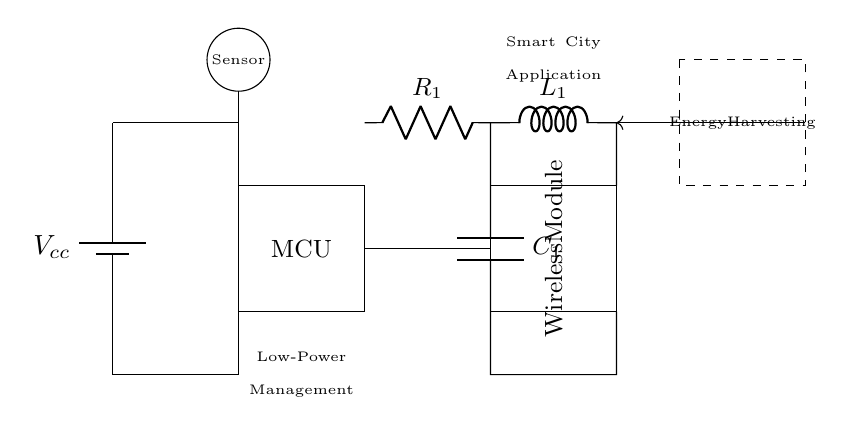What is the power source in this circuit? The power source is a battery, labeled as Vcc. It provides the necessary voltage to the circuit components.
Answer: battery What component is represented by the rectangle on the left side? The rectangle on the left side represents the microcontroller, indicated by the label MCU. A microcontroller processes signals and commands in the circuit.
Answer: MCU What is the function of the energy harvesting component? The energy harvesting component, depicted by the dashed rectangle, is designed to collect and convert energy from the environment to supply power to the circuit, enhancing its efficiency.
Answer: collects energy What type of circuit is this? This circuit is a low-power circuit intended for wireless sensors in smart city applications, which is reflective in its design and components used.
Answer: low-power Which component connects the sensor and the microcontroller? The connection from the sensor to the microcontroller is represented by a wire that leads directly from the sensor circle to the MCU rectangle.
Answer: wire What components make up the energy-efficient part of this circuit? The energy-efficient part comprises a resistor, an inductor, and a capacitor, which help manage and optimize energy usage in the circuit.
Answer: resistor, inductor, capacitor What is the role of the wireless module? The wireless module facilitates communication by transmitting data from the circuit wirelessly, allowing it to connect to other devices or networks.
Answer: transmits data 